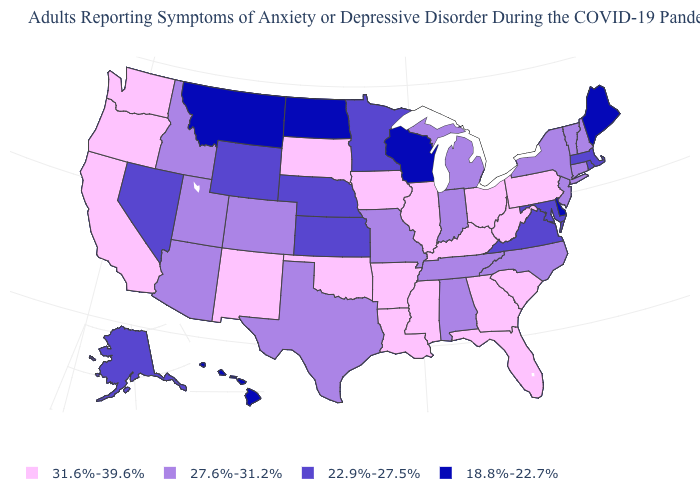What is the value of Utah?
Be succinct. 27.6%-31.2%. What is the value of Connecticut?
Concise answer only. 27.6%-31.2%. How many symbols are there in the legend?
Keep it brief. 4. What is the value of North Carolina?
Concise answer only. 27.6%-31.2%. Name the states that have a value in the range 27.6%-31.2%?
Keep it brief. Alabama, Arizona, Colorado, Connecticut, Idaho, Indiana, Michigan, Missouri, New Hampshire, New Jersey, New York, North Carolina, Tennessee, Texas, Utah, Vermont. Name the states that have a value in the range 22.9%-27.5%?
Quick response, please. Alaska, Kansas, Maryland, Massachusetts, Minnesota, Nebraska, Nevada, Rhode Island, Virginia, Wyoming. Which states have the lowest value in the USA?
Keep it brief. Delaware, Hawaii, Maine, Montana, North Dakota, Wisconsin. What is the value of North Dakota?
Be succinct. 18.8%-22.7%. What is the lowest value in states that border New Hampshire?
Quick response, please. 18.8%-22.7%. Is the legend a continuous bar?
Write a very short answer. No. Which states have the lowest value in the USA?
Quick response, please. Delaware, Hawaii, Maine, Montana, North Dakota, Wisconsin. Is the legend a continuous bar?
Quick response, please. No. What is the lowest value in the USA?
Be succinct. 18.8%-22.7%. Name the states that have a value in the range 22.9%-27.5%?
Short answer required. Alaska, Kansas, Maryland, Massachusetts, Minnesota, Nebraska, Nevada, Rhode Island, Virginia, Wyoming. What is the highest value in the USA?
Keep it brief. 31.6%-39.6%. 